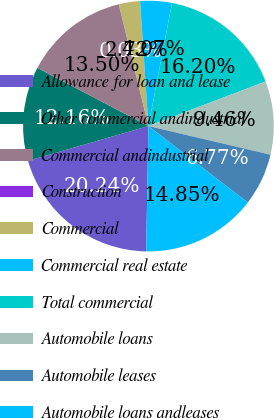Convert chart. <chart><loc_0><loc_0><loc_500><loc_500><pie_chart><fcel>Allowance for loan and lease<fcel>Other commercial andindustrial<fcel>Commercial andindustrial<fcel>Construction<fcel>Commercial<fcel>Commercial real estate<fcel>Total commercial<fcel>Automobile loans<fcel>Automobile leases<fcel>Automobile loans andleases<nl><fcel>20.24%<fcel>12.16%<fcel>13.5%<fcel>0.03%<fcel>2.72%<fcel>4.07%<fcel>16.2%<fcel>9.46%<fcel>6.77%<fcel>14.85%<nl></chart> 